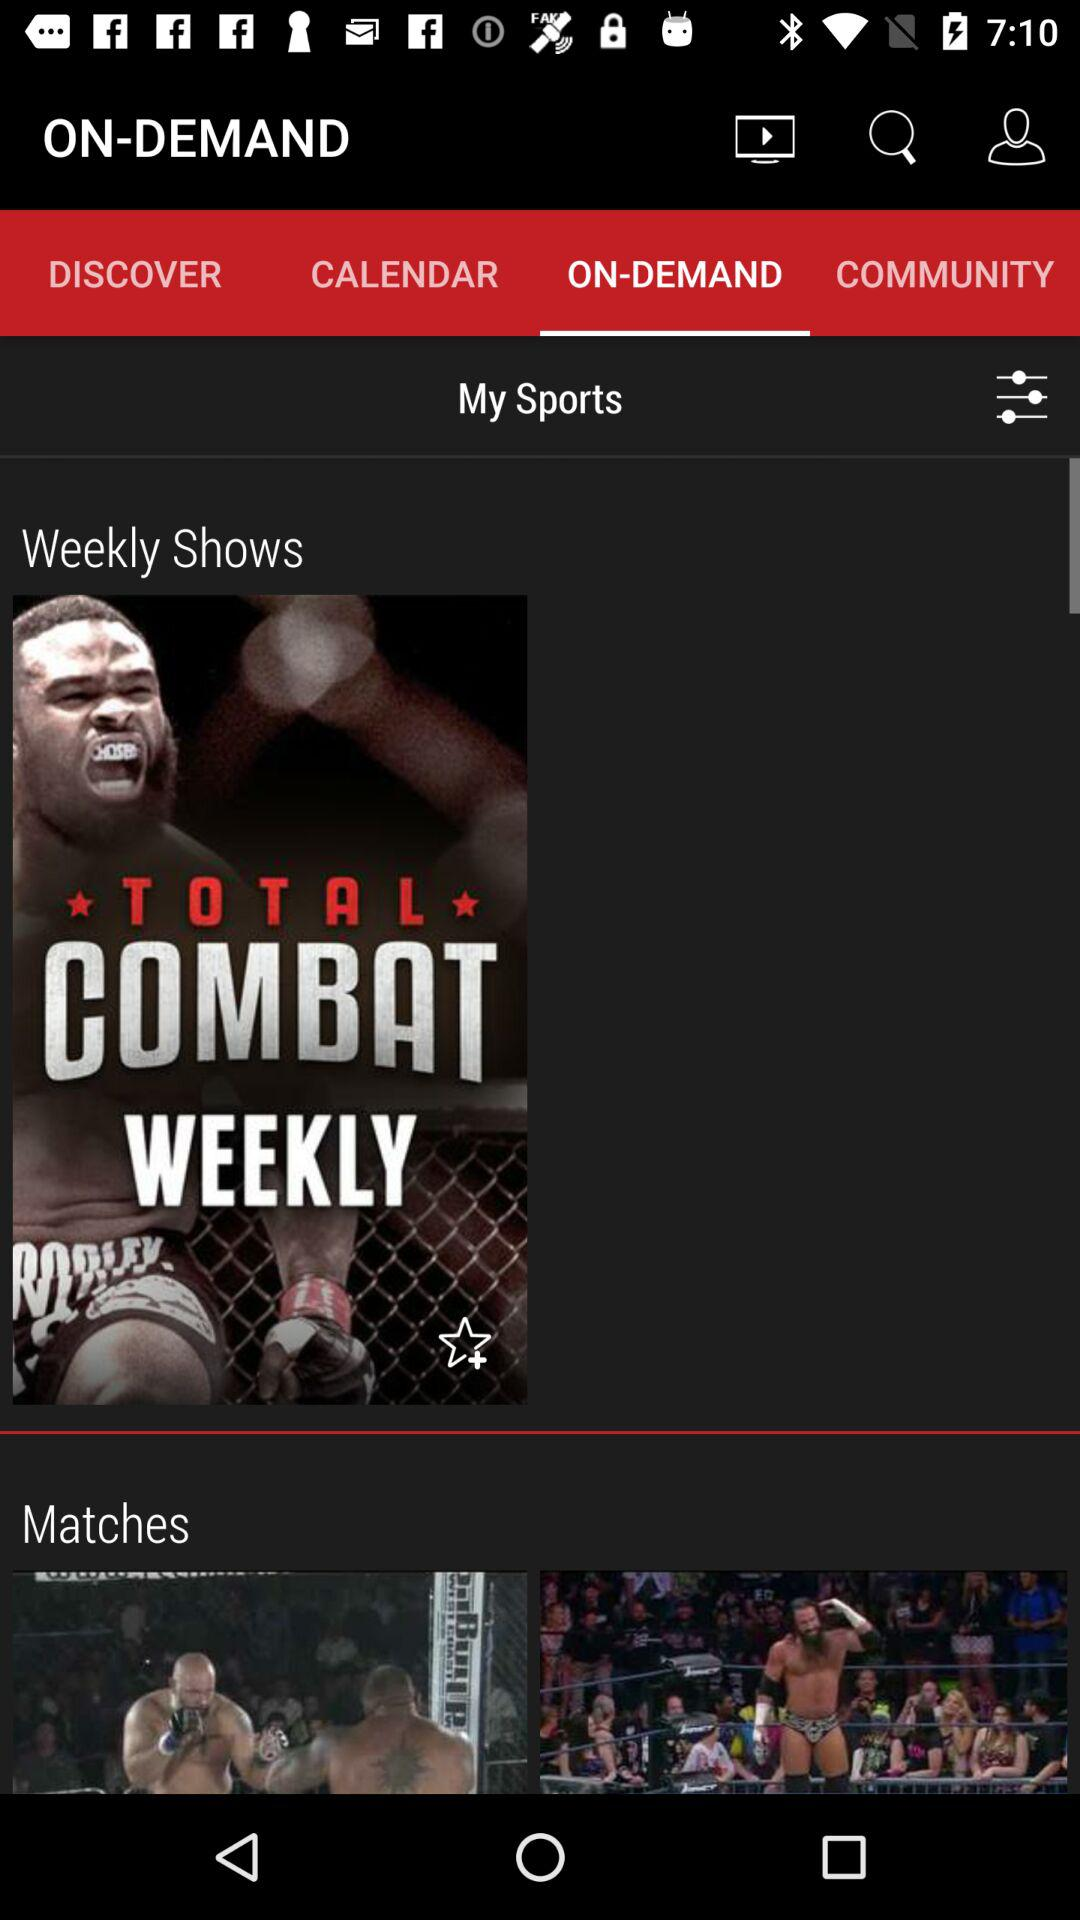What's the name of the weekly show? The name is "TOTAL COMBAT WEEKLY". 